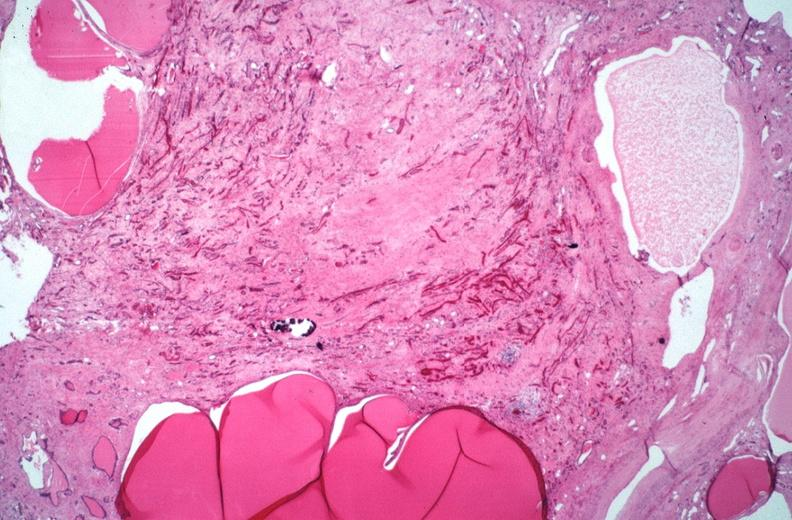does this image show kidney, adult polycystic kidney?
Answer the question using a single word or phrase. Yes 